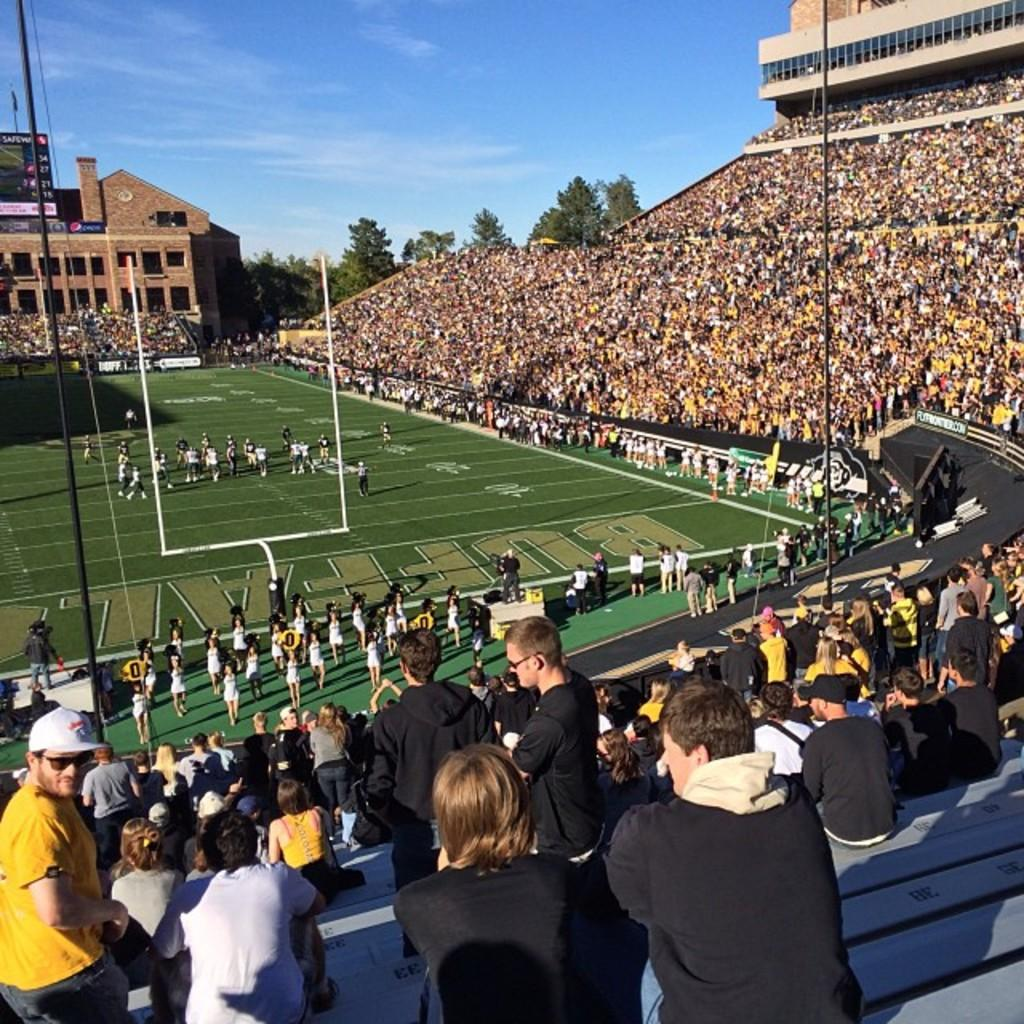Where was the image taken? The image was taken in a rugby stadium. What can be seen on the field in the image? There are many people sitting around the play field. What is visible in the background of the image? There is a building in the background, and trees are present behind the building. What is the condition of the sky in the image? The sky is visible with clouds in the image. Can you tell me how many tigers are present in the image? There are no tigers present in the image. What type of calendar is visible on the field? There is no calendar visible in the image. 